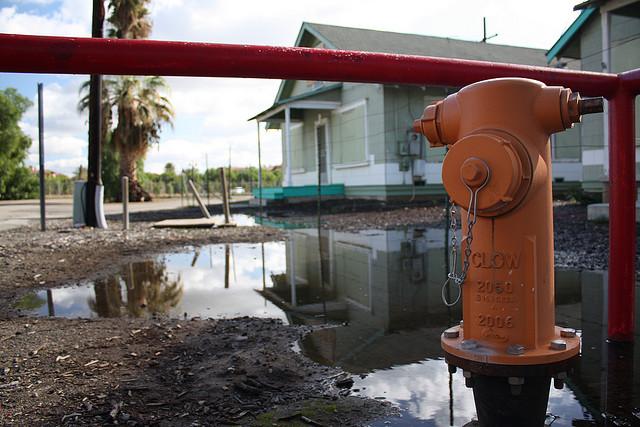What color is the fire hydrant?
Give a very brief answer. Orange. Is there water in the picture?
Answer briefly. Yes. Is this taken at night?
Short answer required. No. 